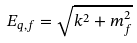Convert formula to latex. <formula><loc_0><loc_0><loc_500><loc_500>E _ { q , f } = \sqrt { k ^ { 2 } + m _ { f } ^ { 2 } }</formula> 